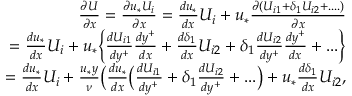Convert formula to latex. <formula><loc_0><loc_0><loc_500><loc_500>\begin{array} { r } { \frac { \partial U } { \partial x } = \frac { \partial u _ { * } U _ { i } } { \partial x } = \frac { d u _ { * } } { d x } U _ { i } + u _ { * } \frac { \partial ( U _ { i 1 } + { \delta _ { 1 } } U _ { i 2 } + \cdots ) } { \partial x } } \\ { = \frac { d u _ { * } } { d x } U _ { i } + u _ { * } \Big \{ \frac { d U _ { i 1 } } { d y ^ { + } } \frac { d y ^ { + } } { d x } + \frac { d \delta _ { 1 } } { d x } U _ { i 2 } + \delta _ { 1 } \frac { d U _ { i 2 } } { d y ^ { + } } \frac { d y ^ { + } } { d x } + \dots \Big \} } \\ { = \frac { d u _ { * } } { d x } U _ { i } + \frac { u _ { * } y } { \nu } \Big ( \frac { d u _ { * } } { d x } \Big ( \frac { d U _ { i 1 } } { d y ^ { + } } + \delta _ { 1 } \frac { d U _ { i 2 } } { d y ^ { + } } + \dots \Big ) + u _ { * } \frac { d \delta _ { 1 } } { d x } U _ { i 2 } , } \end{array}</formula> 